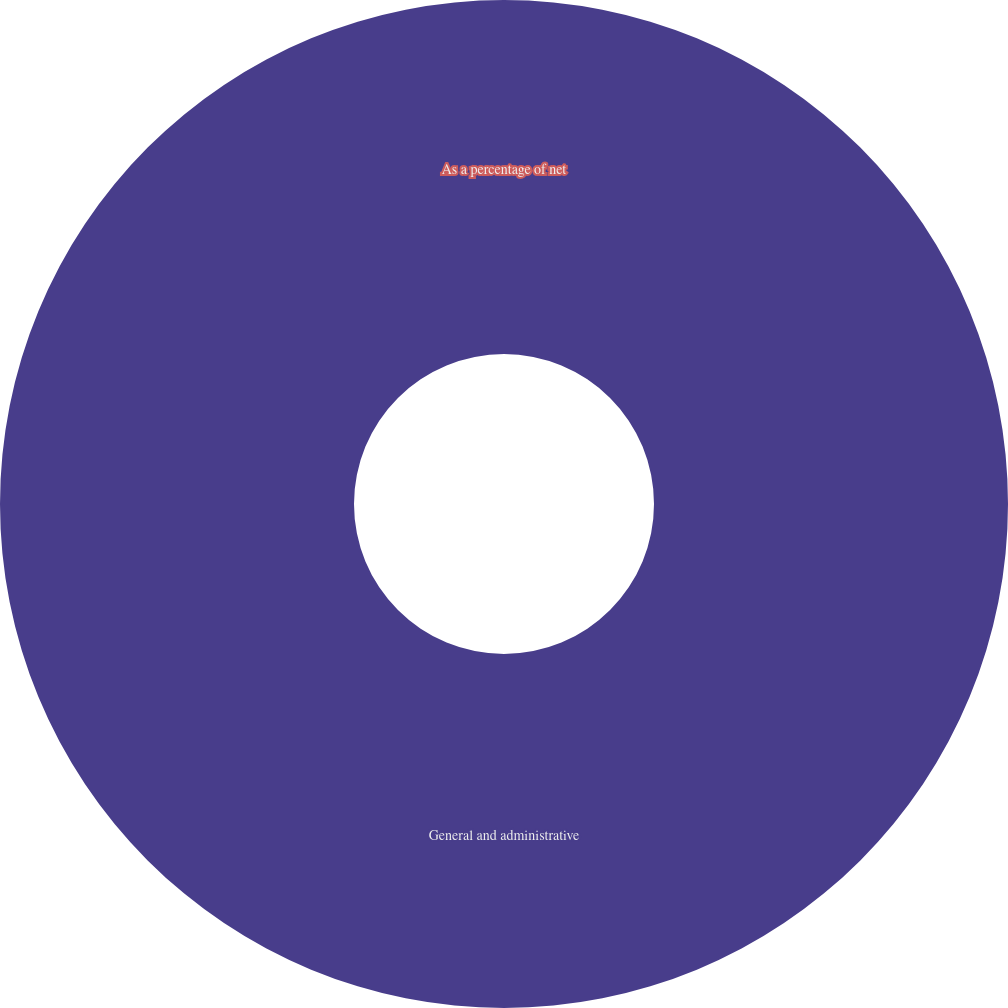Convert chart to OTSL. <chart><loc_0><loc_0><loc_500><loc_500><pie_chart><fcel>General and administrative<fcel>As a percentage of net<nl><fcel>100.0%<fcel>0.0%<nl></chart> 